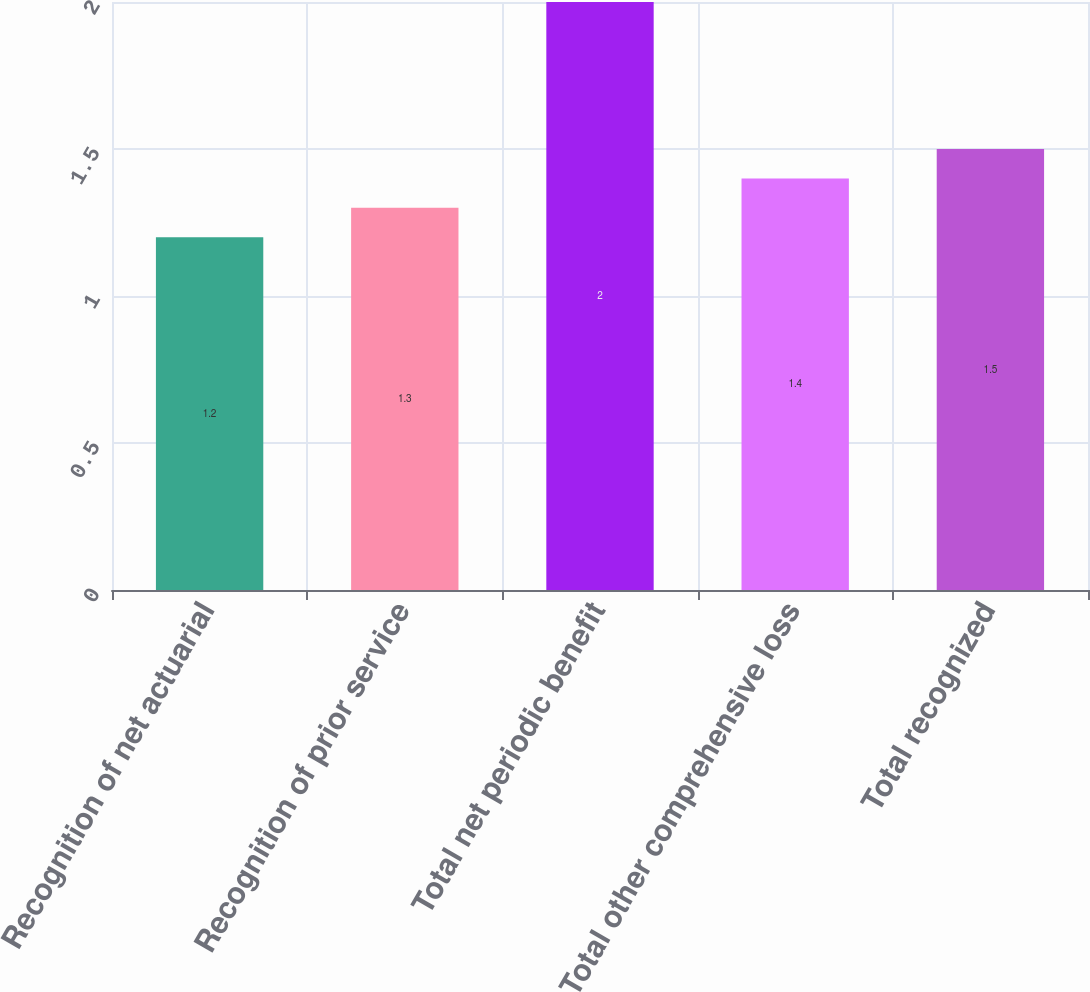Convert chart to OTSL. <chart><loc_0><loc_0><loc_500><loc_500><bar_chart><fcel>Recognition of net actuarial<fcel>Recognition of prior service<fcel>Total net periodic benefit<fcel>Total other comprehensive loss<fcel>Total recognized<nl><fcel>1.2<fcel>1.3<fcel>2<fcel>1.4<fcel>1.5<nl></chart> 